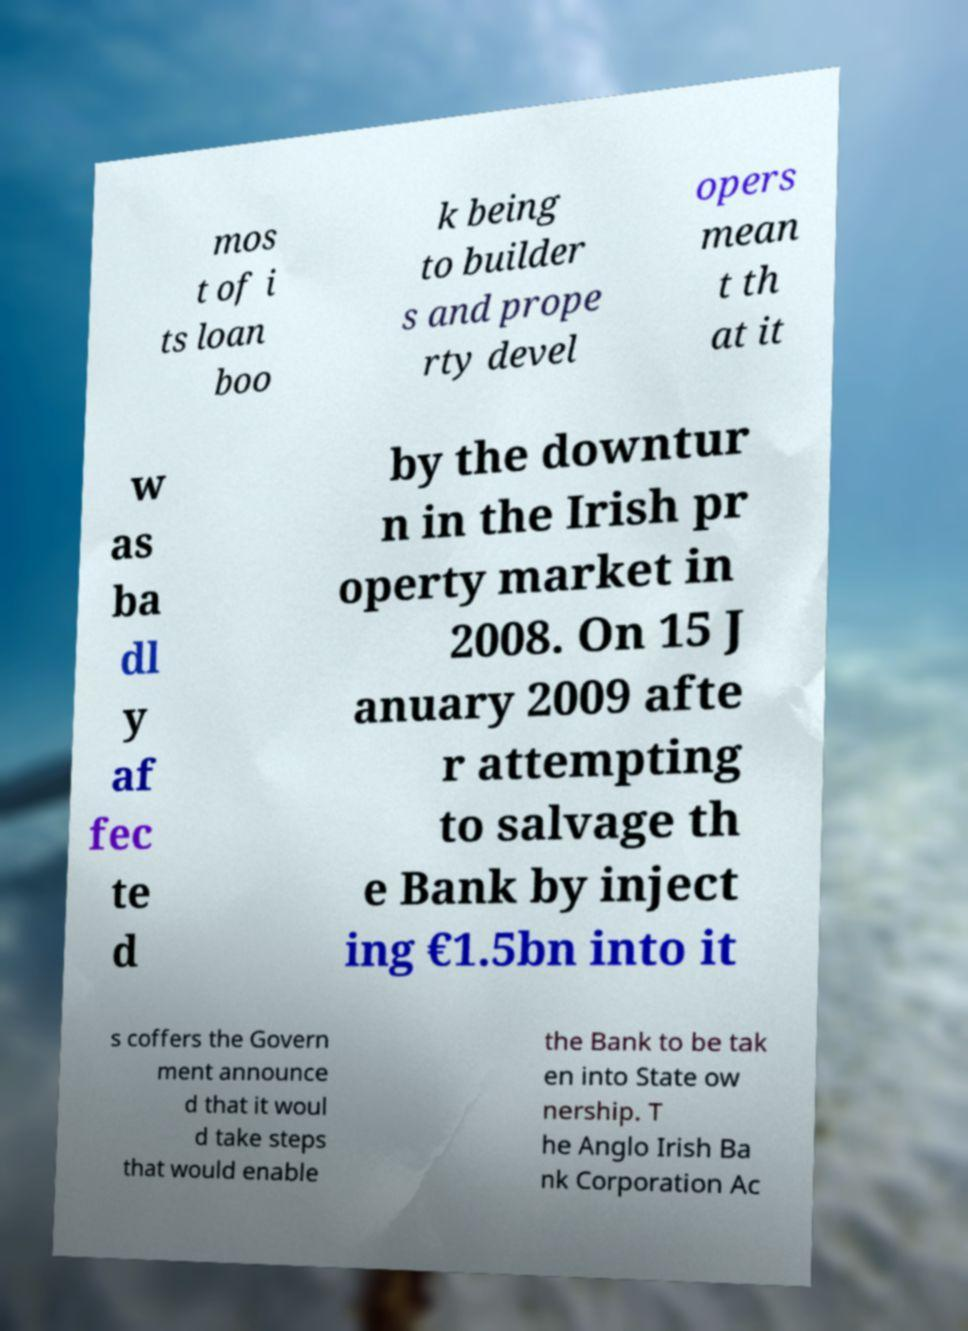For documentation purposes, I need the text within this image transcribed. Could you provide that? mos t of i ts loan boo k being to builder s and prope rty devel opers mean t th at it w as ba dl y af fec te d by the downtur n in the Irish pr operty market in 2008. On 15 J anuary 2009 afte r attempting to salvage th e Bank by inject ing €1.5bn into it s coffers the Govern ment announce d that it woul d take steps that would enable the Bank to be tak en into State ow nership. T he Anglo Irish Ba nk Corporation Ac 